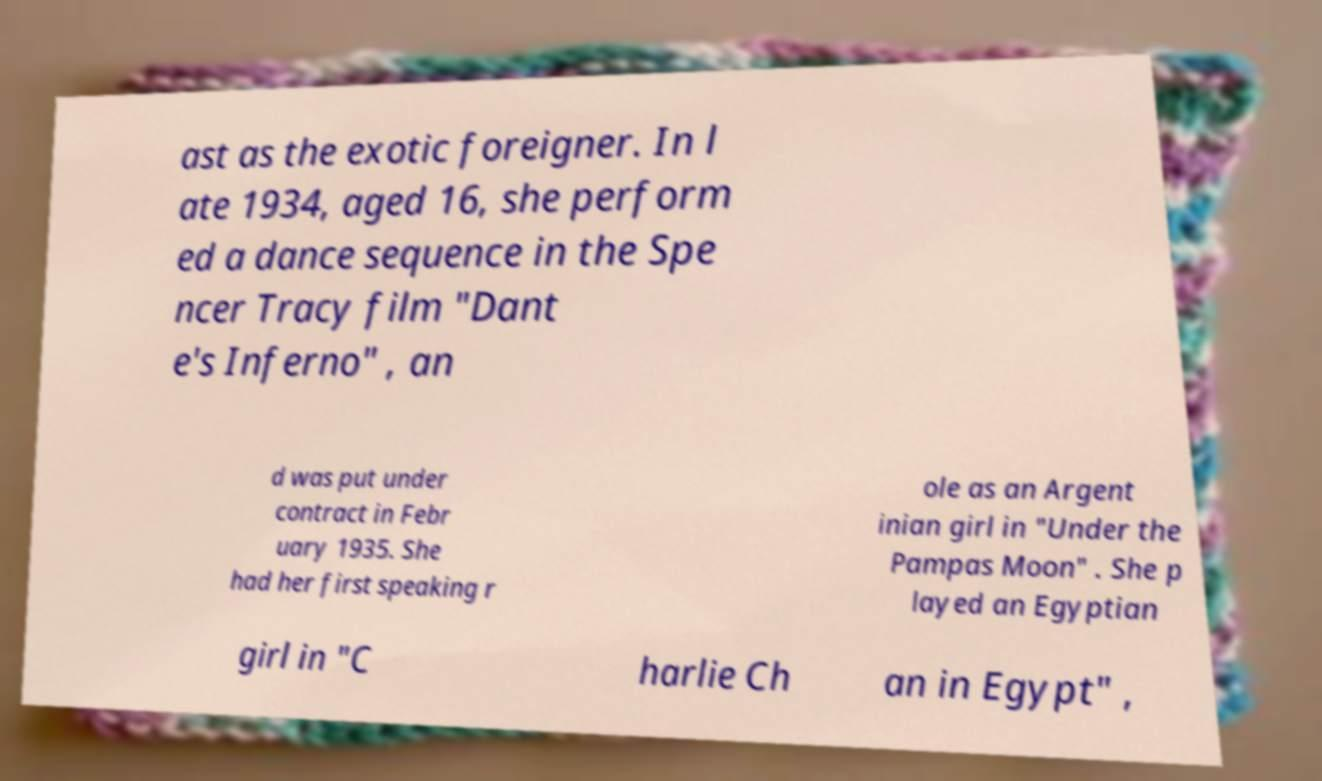Please identify and transcribe the text found in this image. ast as the exotic foreigner. In l ate 1934, aged 16, she perform ed a dance sequence in the Spe ncer Tracy film "Dant e's Inferno" , an d was put under contract in Febr uary 1935. She had her first speaking r ole as an Argent inian girl in "Under the Pampas Moon" . She p layed an Egyptian girl in "C harlie Ch an in Egypt" , 